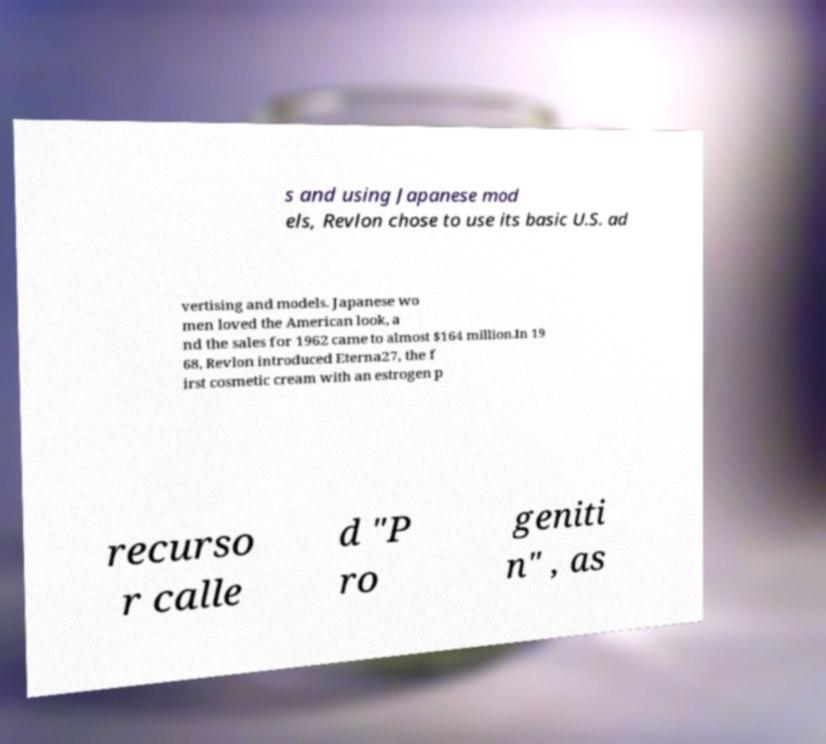Please read and relay the text visible in this image. What does it say? s and using Japanese mod els, Revlon chose to use its basic U.S. ad vertising and models. Japanese wo men loved the American look, a nd the sales for 1962 came to almost $164 million.In 19 68, Revlon introduced Eterna27, the f irst cosmetic cream with an estrogen p recurso r calle d "P ro geniti n" , as 